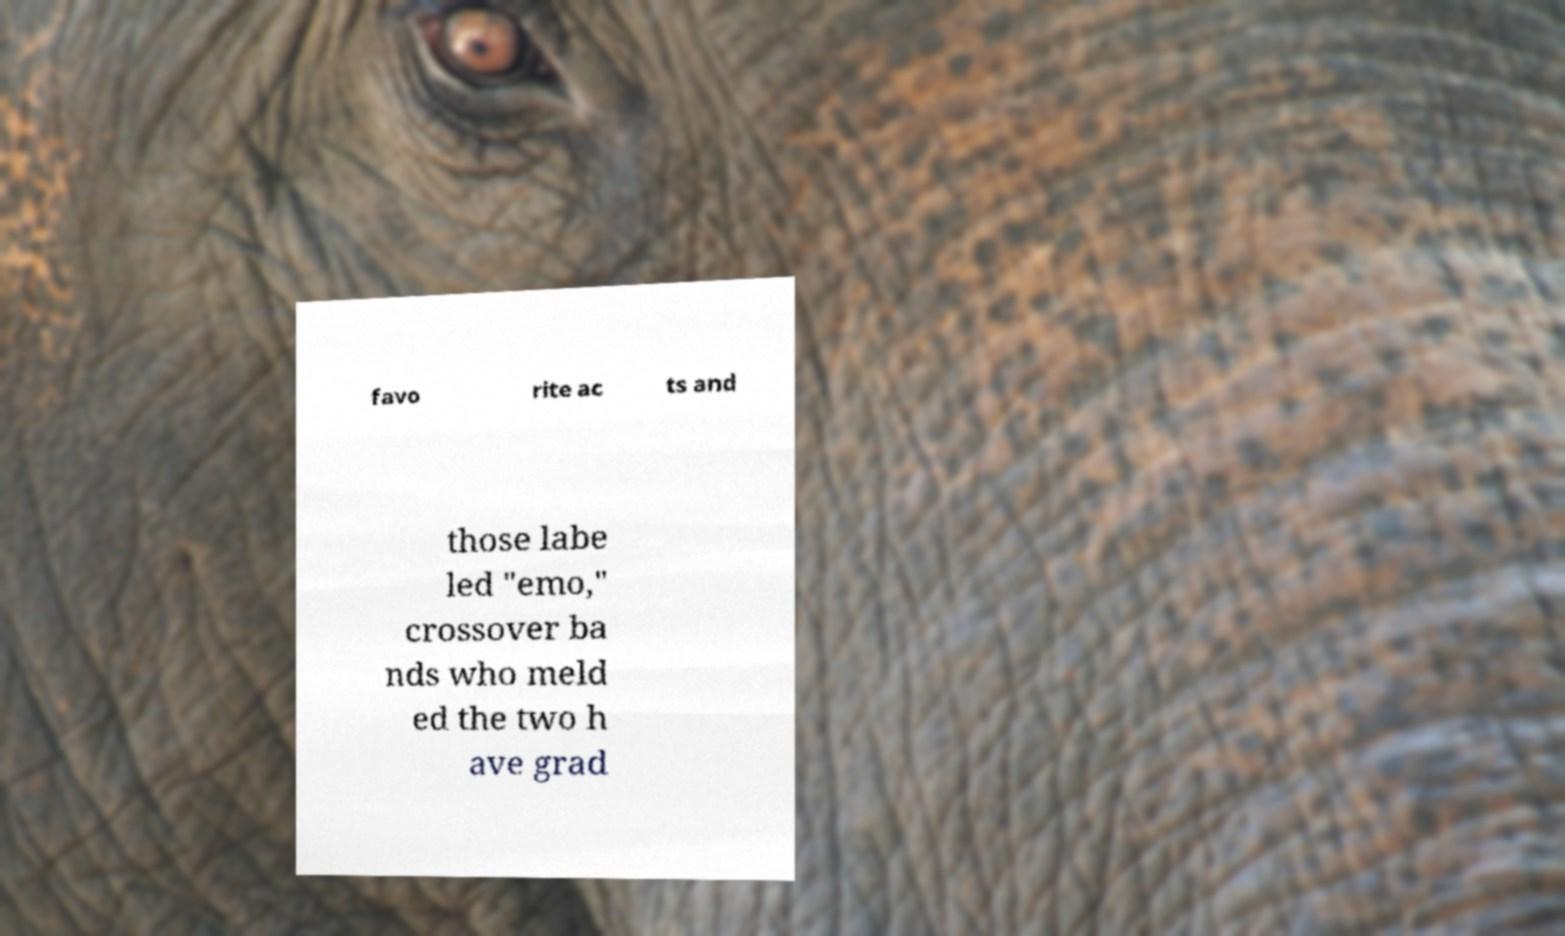Could you extract and type out the text from this image? favo rite ac ts and those labe led "emo," crossover ba nds who meld ed the two h ave grad 